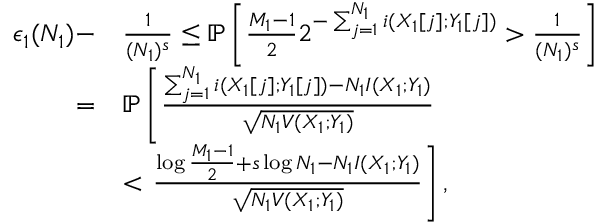<formula> <loc_0><loc_0><loc_500><loc_500>\begin{array} { r l } { \epsilon _ { 1 } ( N _ { 1 } ) - } & { \frac { 1 } { ( N _ { 1 } ) ^ { s } } \leq \mathbb { P } \left [ \frac { M _ { 1 } - 1 } { 2 } 2 ^ { - \sum _ { j = 1 } ^ { N _ { 1 } } i ( X _ { 1 } [ j ] ; Y _ { 1 } [ j ] ) } > \frac { 1 } { ( N _ { 1 } ) ^ { s } } \right ] } \\ { = } & { \mathbb { P } \left [ \frac { \sum _ { j = 1 } ^ { N _ { 1 } } i ( X _ { 1 } [ j ] ; Y _ { 1 } [ j ] ) - N _ { 1 } I ( X _ { 1 } ; Y _ { 1 } ) } { \sqrt { N _ { 1 } V ( X _ { 1 } ; Y _ { 1 } ) } } } \\ & { < \frac { \log \frac { M _ { 1 } - 1 } { 2 } + s \log N _ { 1 } - N _ { 1 } I ( X _ { 1 } ; Y _ { 1 } ) } { \sqrt { N _ { 1 } V ( X _ { 1 } ; Y _ { 1 } ) } } \right ] , } \end{array}</formula> 